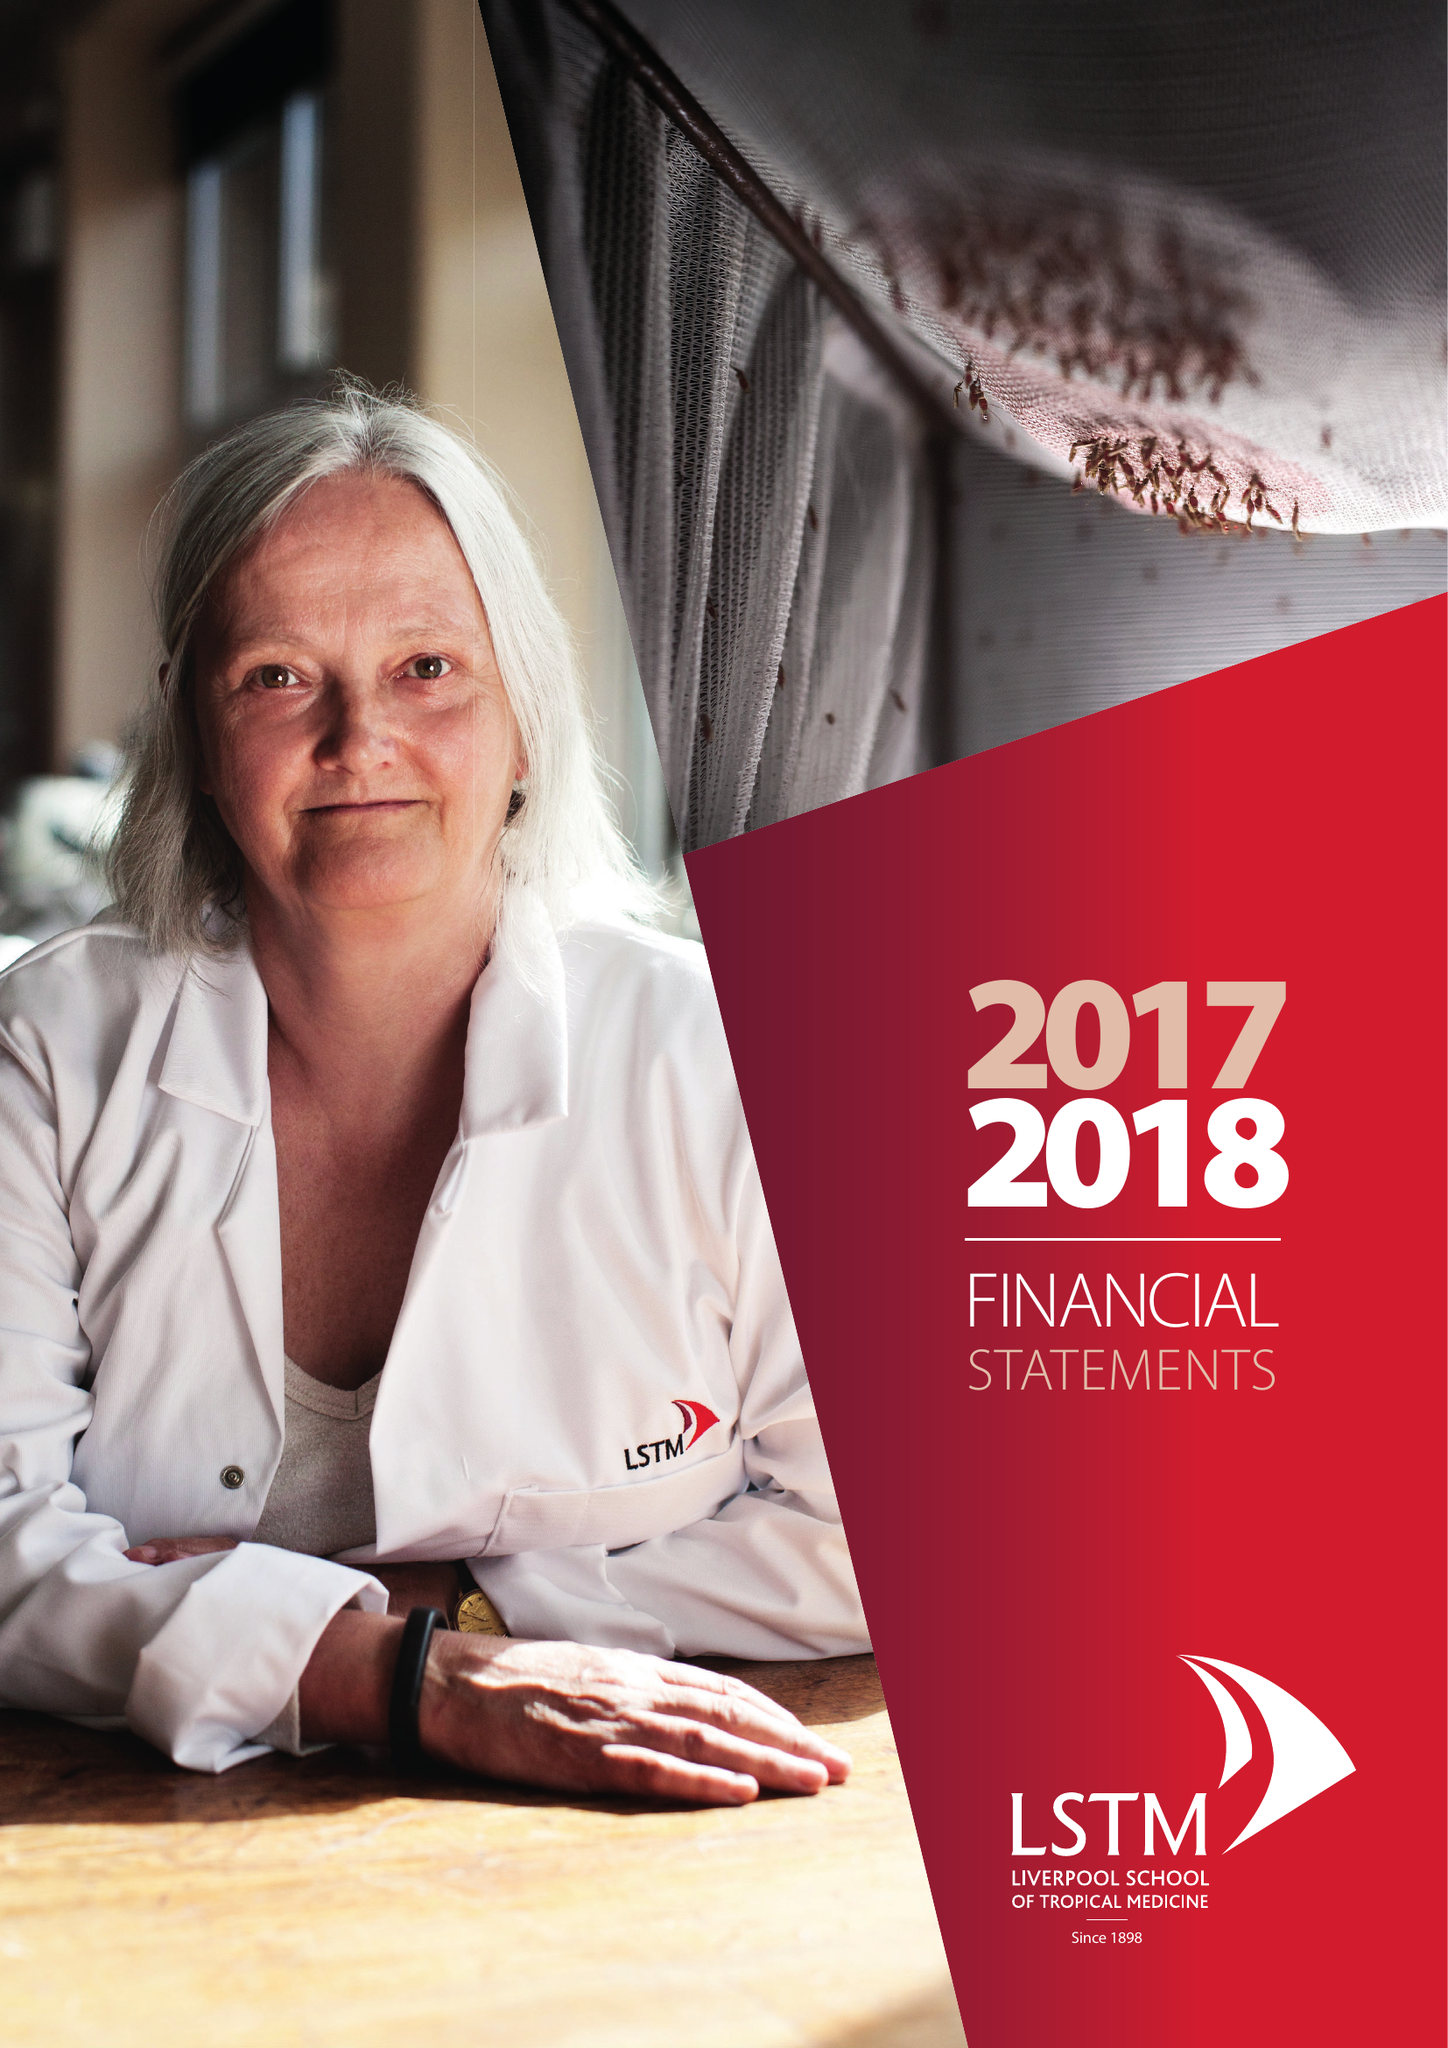What is the value for the income_annually_in_british_pounds?
Answer the question using a single word or phrase. 232397000.00 